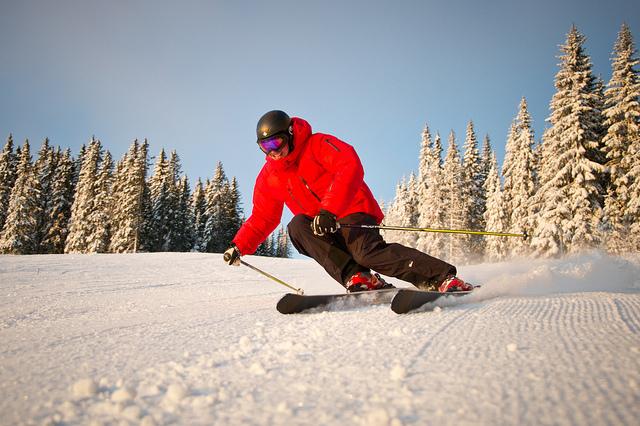Has the snow been groomed?
Give a very brief answer. Yes. Is the person on grass?
Keep it brief. No. What is the person doing?
Concise answer only. Skiing. 